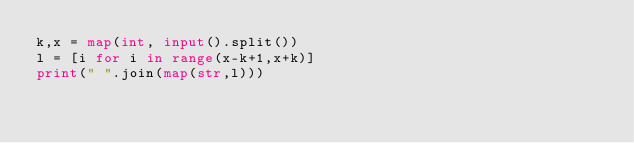<code> <loc_0><loc_0><loc_500><loc_500><_Python_>k,x = map(int, input().split())
l = [i for i in range(x-k+1,x+k)]
print(" ".join(map(str,l))) 
  </code> 